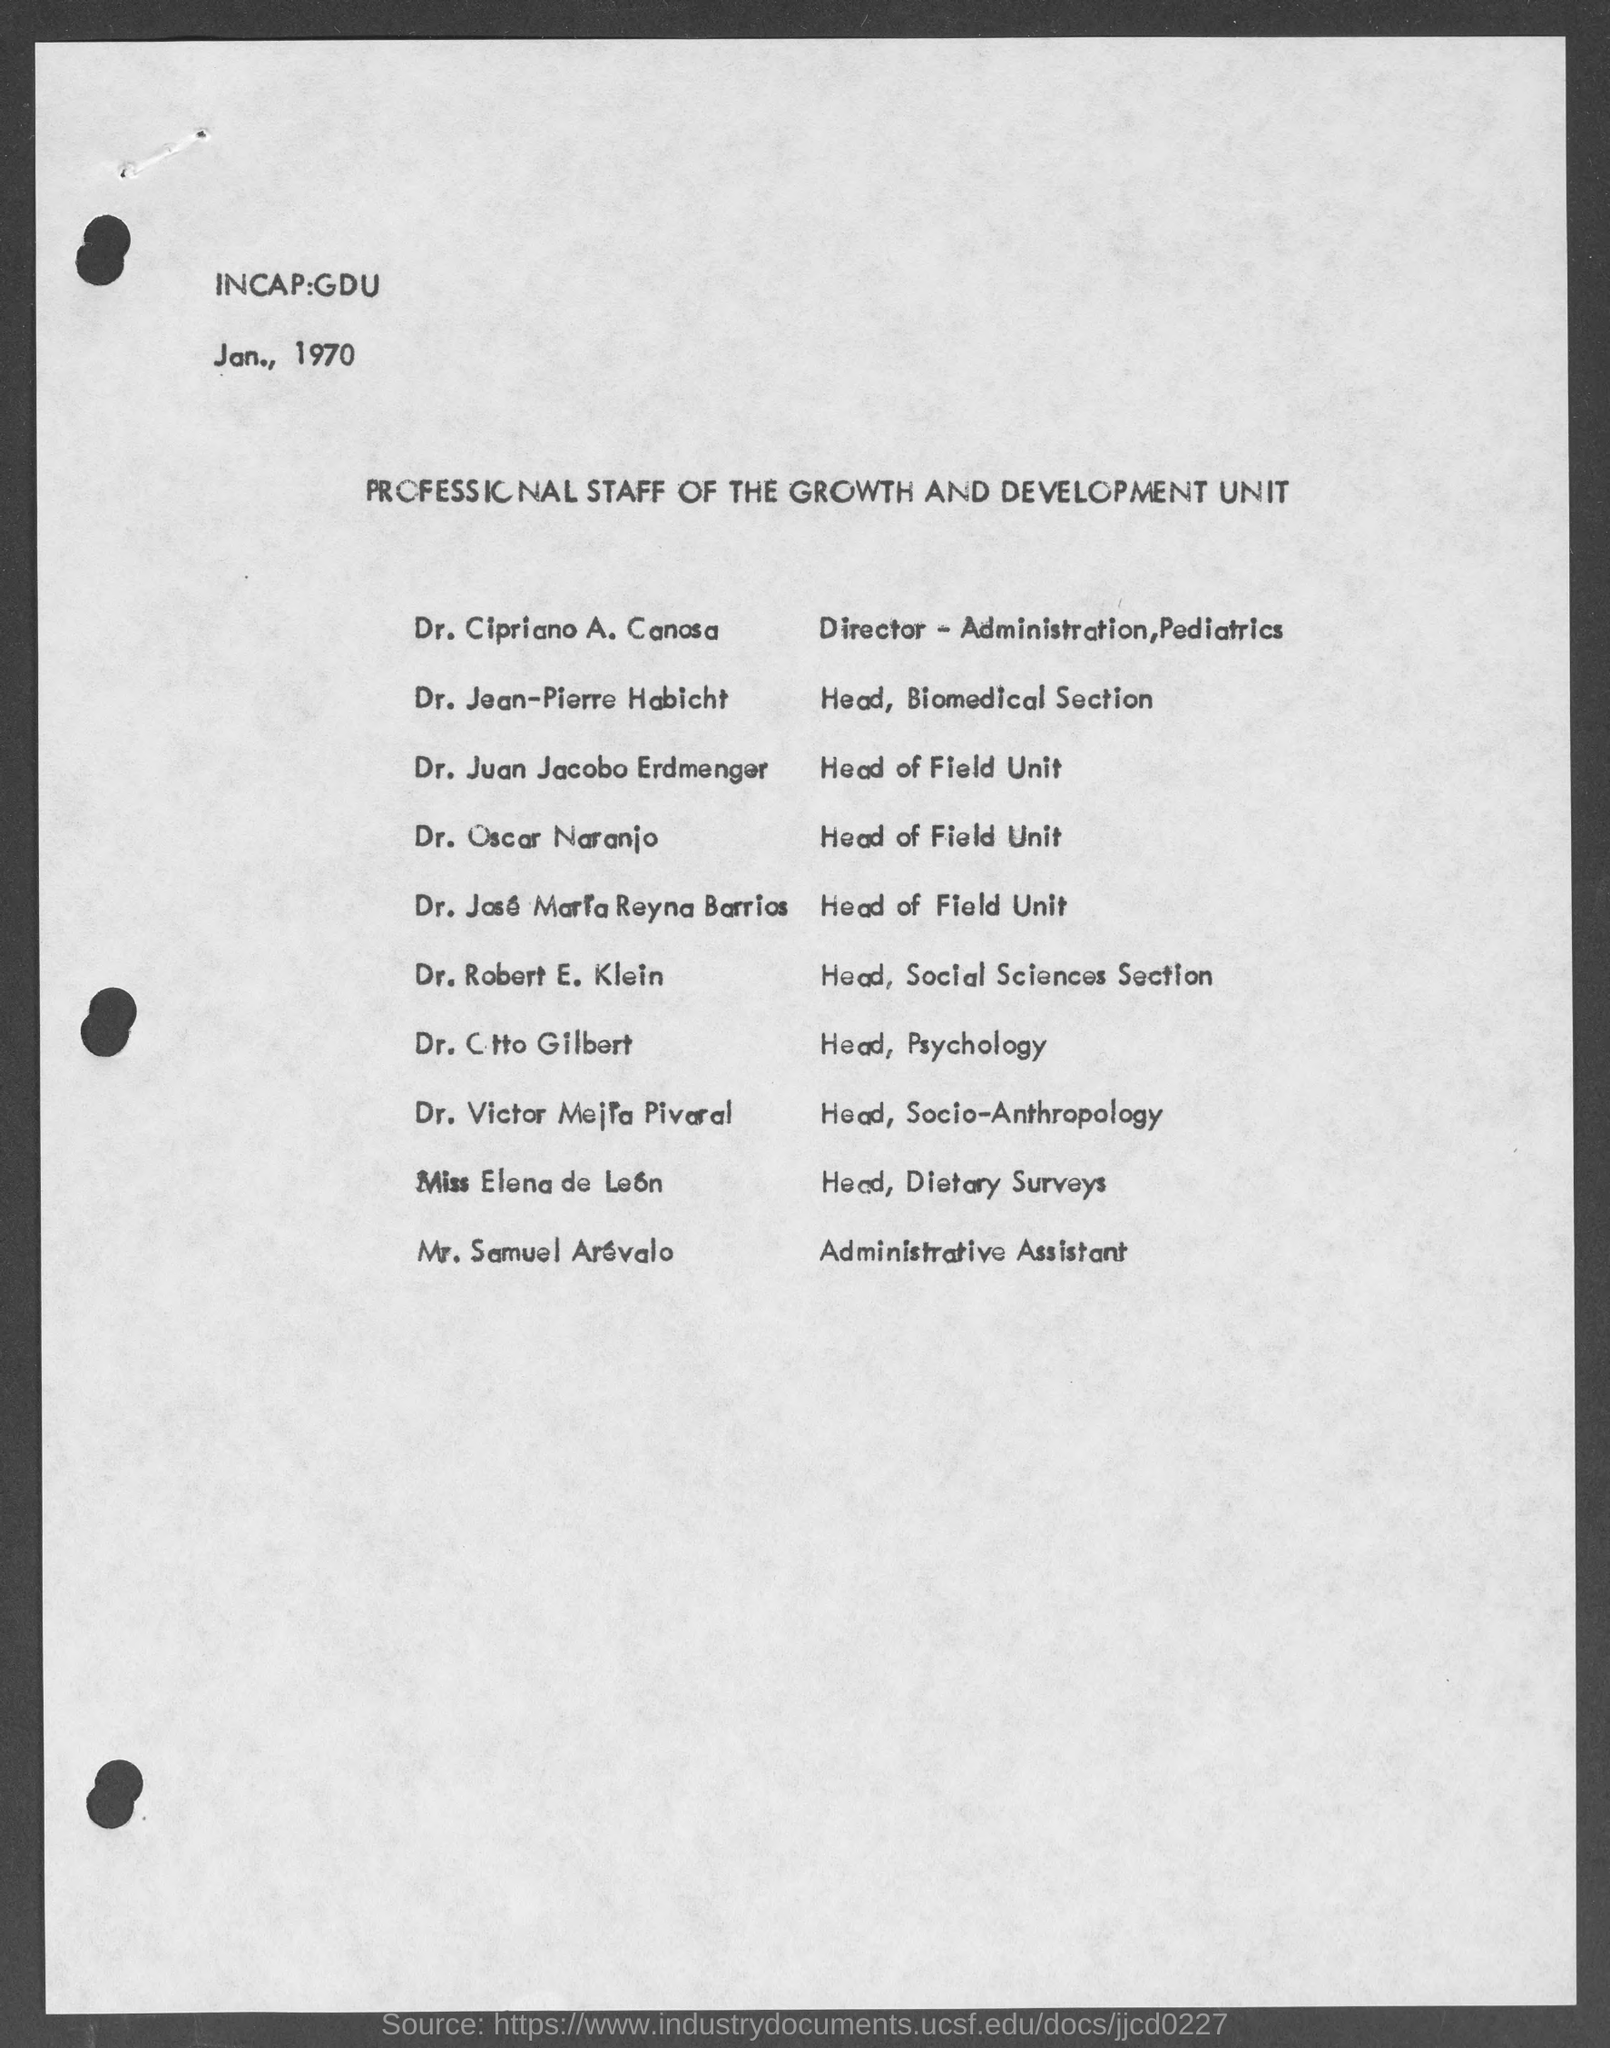What is the date mentioned?
Your answer should be very brief. Jan., 1970. What is the given document about?
Offer a very short reply. Professional staff of the growth and development unit. Who is the director-administration,pediatrics
Provide a succinct answer. Dr. cipriano a. canosa. Who is the head,psychology?
Ensure brevity in your answer.  Dr. ctto gilbert. Who is the administrative assistant?
Provide a succinct answer. Mr. samuel arevalo. 